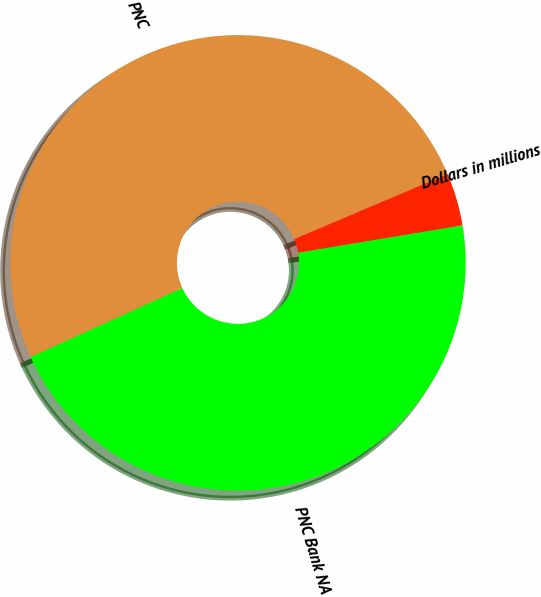Convert chart. <chart><loc_0><loc_0><loc_500><loc_500><pie_chart><fcel>Dollars in millions<fcel>PNC<fcel>PNC Bank NA<nl><fcel>3.76%<fcel>50.41%<fcel>45.83%<nl></chart> 